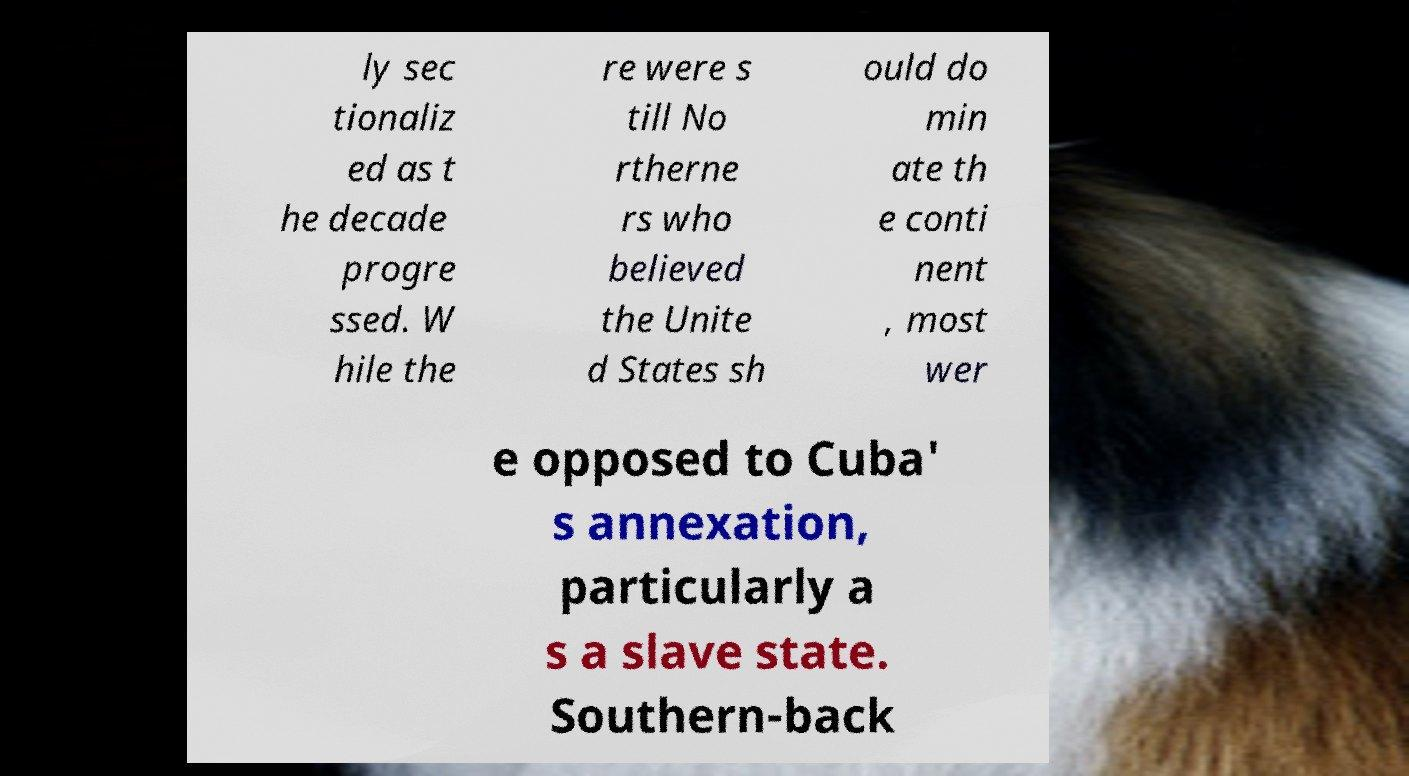Could you assist in decoding the text presented in this image and type it out clearly? ly sec tionaliz ed as t he decade progre ssed. W hile the re were s till No rtherne rs who believed the Unite d States sh ould do min ate th e conti nent , most wer e opposed to Cuba' s annexation, particularly a s a slave state. Southern-back 